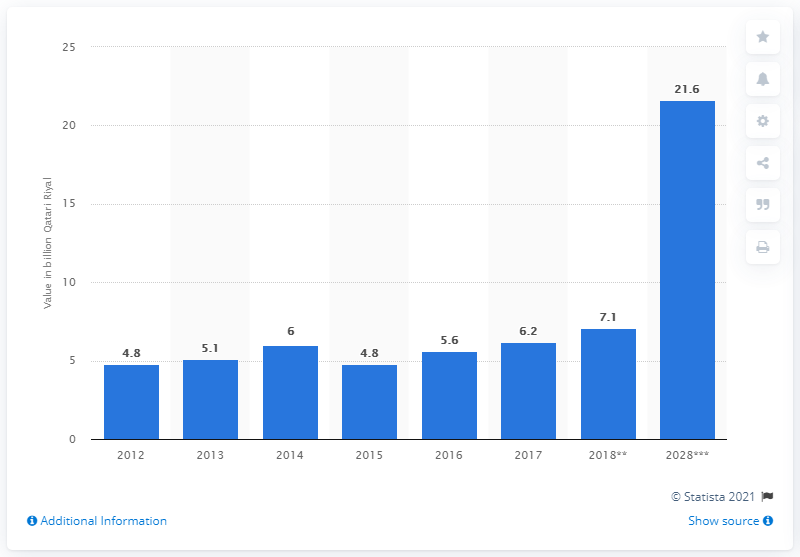Point out several critical features in this image. According to estimates, by 2028, tourism is projected to contribute QR 21.6 billion to the Gross Domestic Product (GDP) of Qatar. 